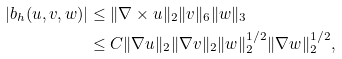Convert formula to latex. <formula><loc_0><loc_0><loc_500><loc_500>| b _ { h } ( u , v , w ) | & \leq \| \nabla \times u \| _ { 2 } \| v \| _ { 6 } \| w \| _ { 3 } \\ & \leq C \| \nabla u \| _ { 2 } \| \nabla v \| _ { 2 } \| w \| _ { 2 } ^ { 1 / 2 } \| \nabla w \| _ { 2 } ^ { 1 / 2 } ,</formula> 